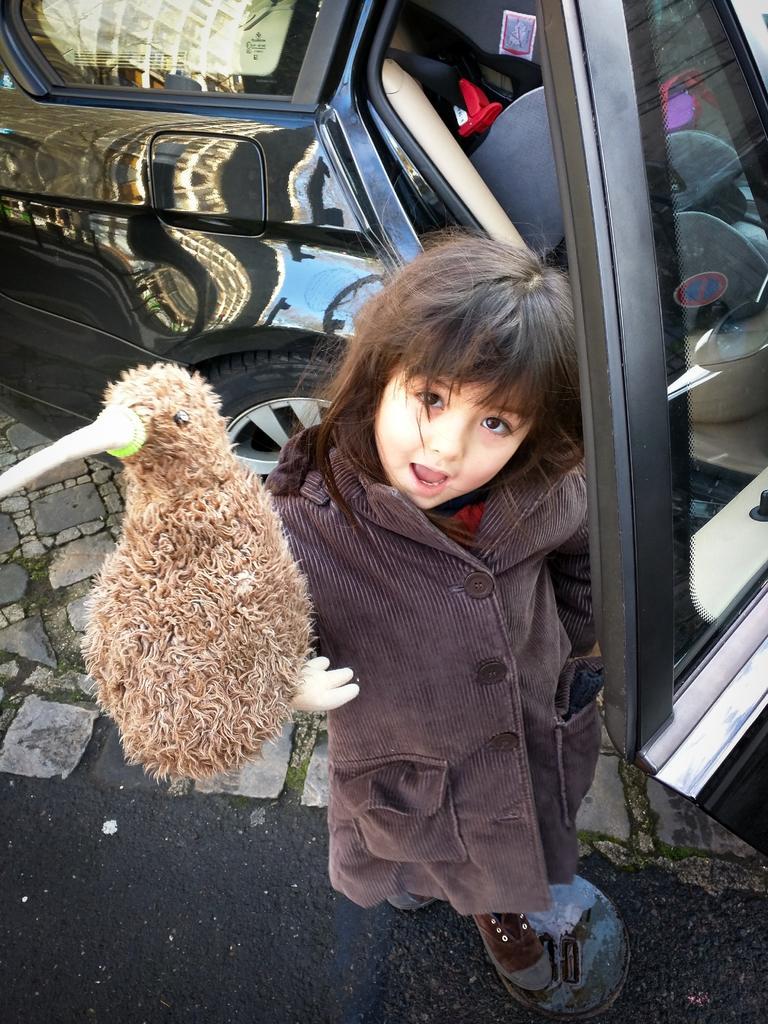In one or two sentences, can you explain what this image depicts? In the picture there is a girl standing and catching a bird, behind her there is a car. 